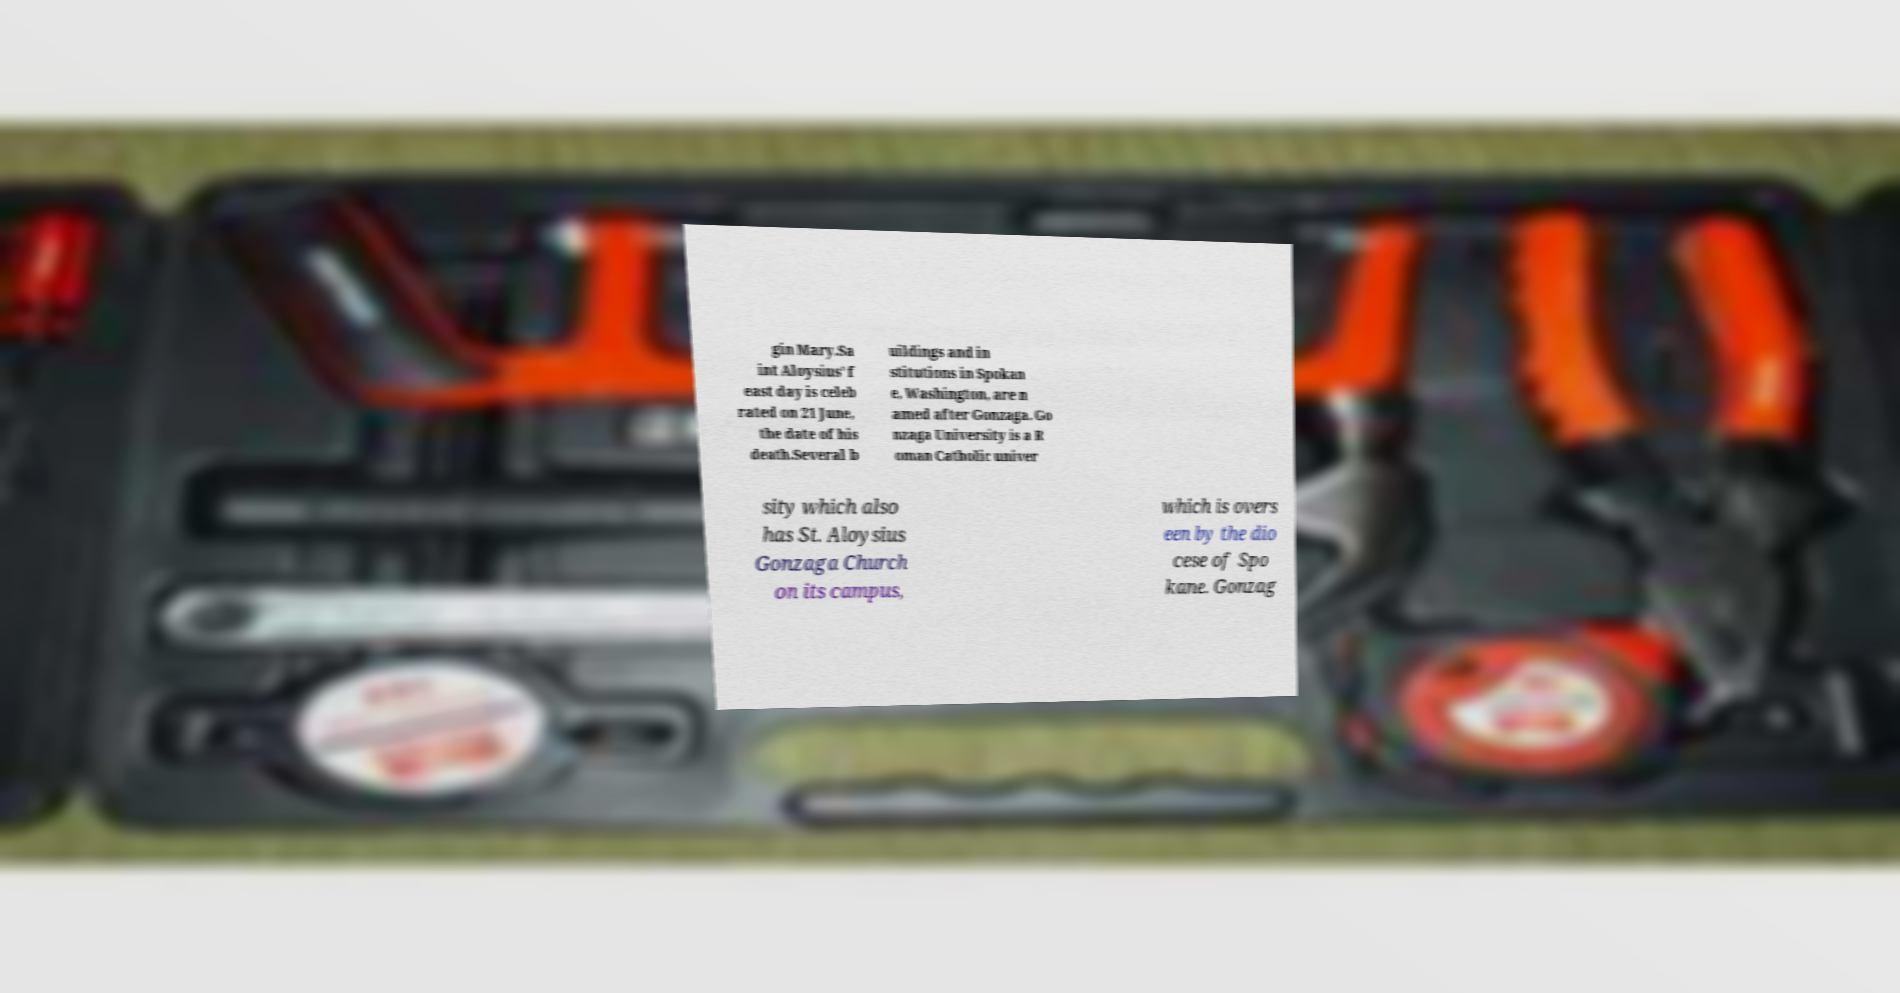Can you accurately transcribe the text from the provided image for me? gin Mary.Sa int Aloysius' f east day is celeb rated on 21 June, the date of his death.Several b uildings and in stitutions in Spokan e, Washington, are n amed after Gonzaga. Go nzaga University is a R oman Catholic univer sity which also has St. Aloysius Gonzaga Church on its campus, which is overs een by the dio cese of Spo kane. Gonzag 